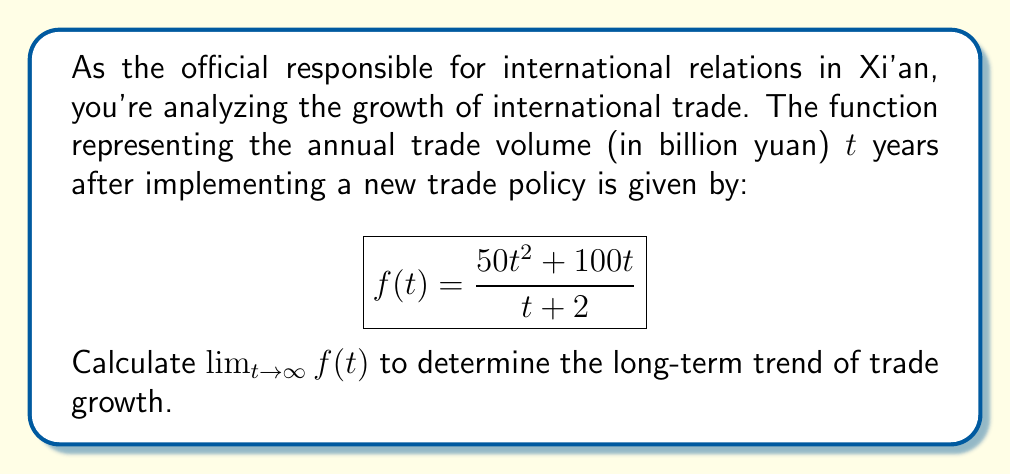Solve this math problem. To find the limit as t approaches infinity, we'll follow these steps:

1) First, let's examine the degree of the numerator and denominator:
   Numerator: $50t^2 + 100t$ (degree 2)
   Denominator: $t + 2$ (degree 1)

2) When the degree of the numerator is higher than the denominator, we can divide both the numerator and denominator by the highest power of t in the denominator:

   $$\lim_{t \to \infty} f(t) = \lim_{t \to \infty} \frac{50t^2 + 100t}{t + 2}$$
   $$= \lim_{t \to \infty} \frac{50t^2 + 100t}{t(1 + \frac{2}{t})}$$

3) Simplify:
   $$= \lim_{t \to \infty} \frac{50t + 100}{1 + \frac{2}{t}}$$

4) As t approaches infinity, $\frac{2}{t}$ approaches 0:
   $$= \lim_{t \to \infty} \frac{50t + 100}{1 + 0} = \lim_{t \to \infty} (50t + 100)$$

5) The limit of a linear function as t approaches infinity is infinity:
   $$= \infty$$

This result indicates that the international trade volume is expected to grow without bound in the long term under the current policy.
Answer: $\infty$ 